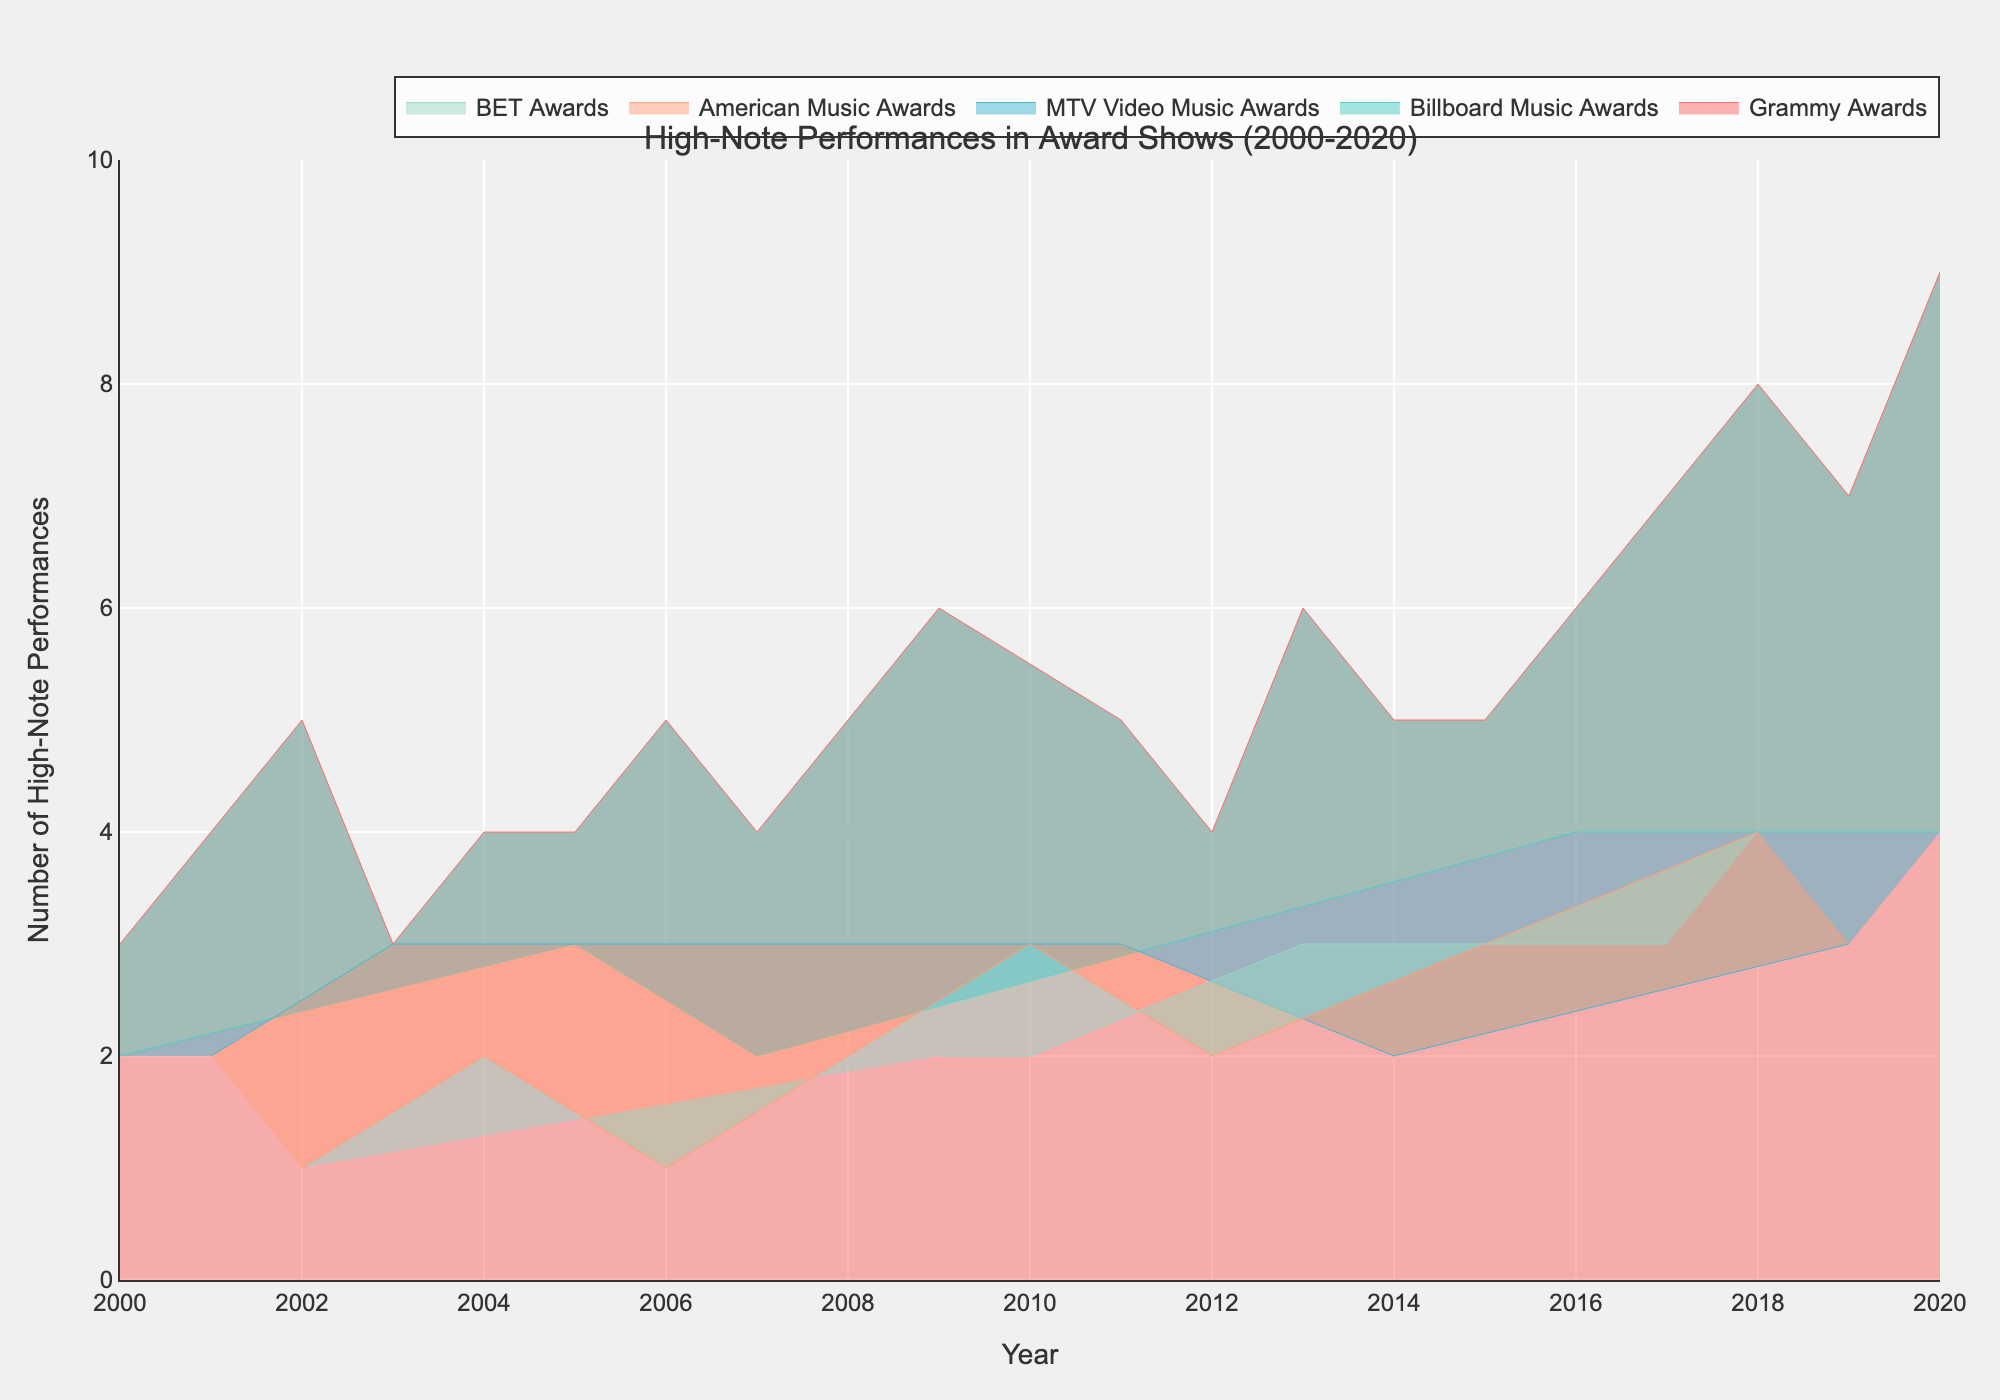What is the title of the chart? The title is usually displayed at the top of the chart, above the plot area. It provides a summary of the data being visualized.
Answer: High-Note Performances in Award Shows (2000-2020) Which event showed the highest number of high-note performances in 2020? By looking at the lines corresponding to the different events in the year 2020 on the x-axis, locate the event with the highest y-value, which indicates the number of high-note performances.
Answer: Grammy Awards How many high-note performances were recorded at the Billboard Music Awards in 2005? Identify the line or area corresponding to the Billboard Music Awards and check the y-value at the year 2005 on the x-axis.
Answer: 3 Which event had more high-note performances in 2013: BET Awards or Grammy Awards? Compare the y-values for BET Awards and Grammy Awards at the year 2013 on the x-axis.
Answer: Grammy Awards What was the increase in the number of high-note performances at the Grammy Awards from 2017 to 2018? Subtract the number of high-note performances in 2017 from the number in 2018 for the Grammy Awards.
Answer: 1 Which event consistently had high-note performances every single year? Determine if any event has lines extending through all years from 2000 to 2020 without any breaks.
Answer: Grammy Awards What was the average number of high-note performances at the MTV Video Music Awards from 2000 to 2020? Sum the number of high-note performances at the MTV Video Music Awards over all years and divide by the number of years they appeared.
Answer: 2.5 Was there any year where the American Music Awards had zero high-note performances? Check each year on the x-axis for the American Music Awards line to see if it ever hits the y-value of zero.
Answer: No In what year did the Grammy Awards surpass 5 high-note performances for the first time? Look at the line for Grammy Awards and identify the first year where its y-value exceeds 5.
Answer: 2009 